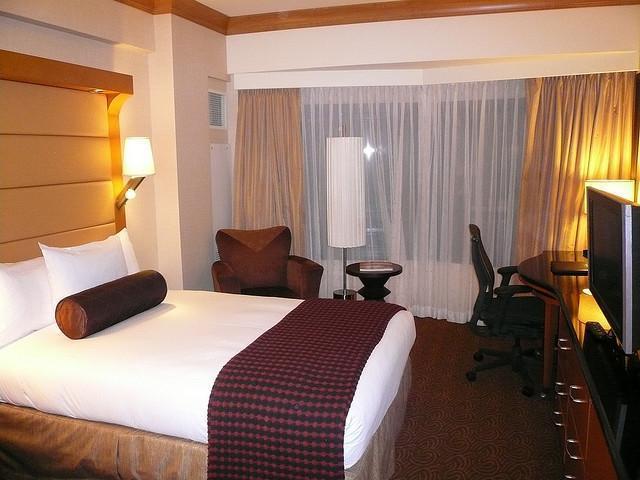How many pillows are on the bed?
Give a very brief answer. 3. How many chairs are in the picture?
Give a very brief answer. 2. How many people ride on the cycle?
Give a very brief answer. 0. 